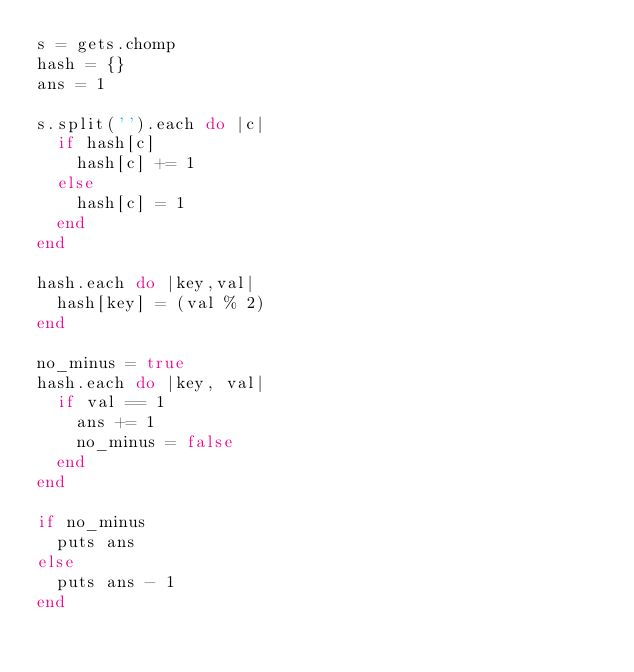<code> <loc_0><loc_0><loc_500><loc_500><_Ruby_>s = gets.chomp
hash = {}
ans = 1

s.split('').each do |c|
  if hash[c]
    hash[c] += 1
  else
    hash[c] = 1
  end
end

hash.each do |key,val|
  hash[key] = (val % 2)
end

no_minus = true
hash.each do |key, val|
  if val == 1
    ans += 1
    no_minus = false
  end
end

if no_minus
  puts ans
else
  puts ans - 1
end</code> 